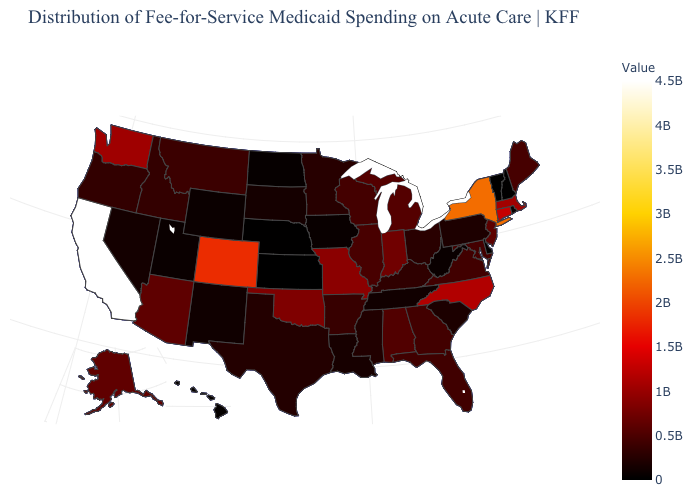Which states hav the highest value in the South?
Concise answer only. North Carolina. Which states have the lowest value in the USA?
Write a very short answer. Vermont. Is the legend a continuous bar?
Answer briefly. Yes. Is the legend a continuous bar?
Keep it brief. Yes. Does Maine have the highest value in the Northeast?
Give a very brief answer. No. Does Indiana have a lower value than Kansas?
Be succinct. No. Among the states that border Arkansas , does Missouri have the highest value?
Give a very brief answer. Yes. Which states have the lowest value in the USA?
Short answer required. Vermont. 